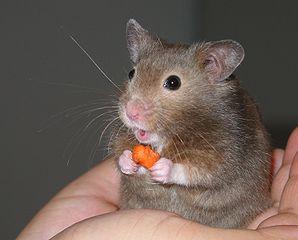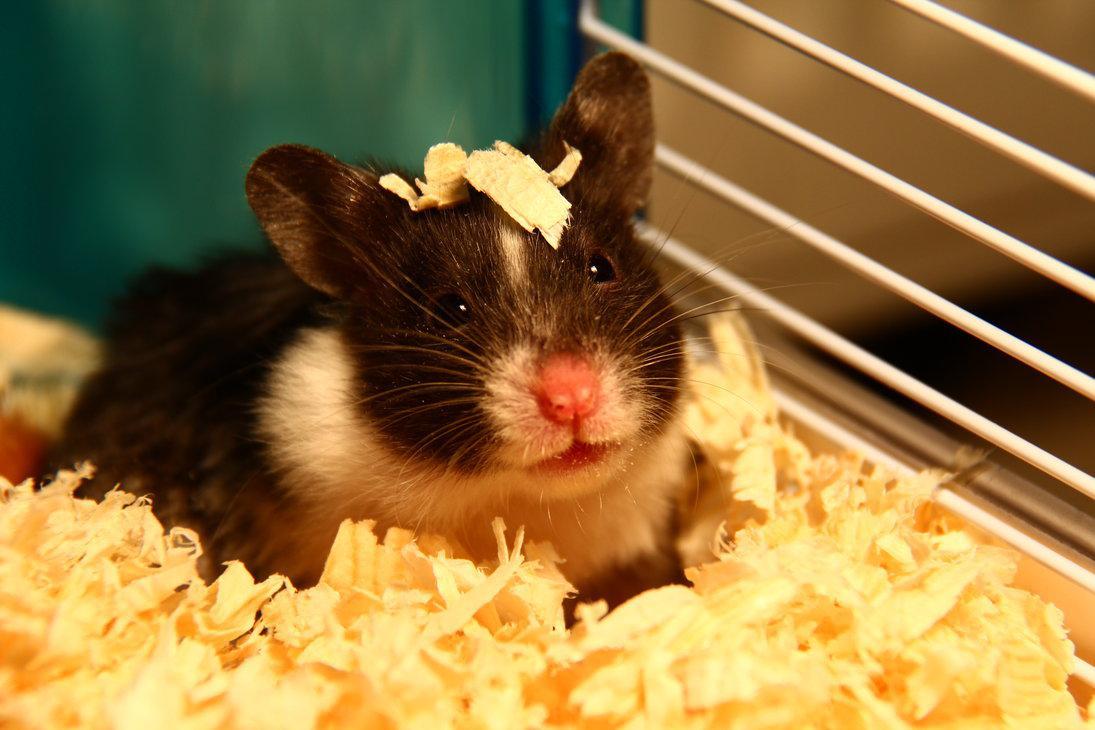The first image is the image on the left, the second image is the image on the right. Assess this claim about the two images: "In at least one of the images, the hamster is holding food". Correct or not? Answer yes or no. Yes. 